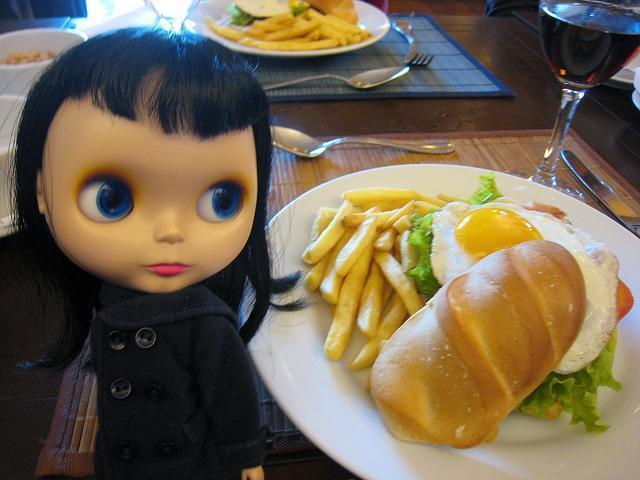Does the caption "The person is touching the sandwich." correctly depict the image?
Answer yes or no. No. Is the caption "The dining table is on the sandwich." a true representation of the image?
Answer yes or no. No. Does the image validate the caption "The sandwich is at the right side of the person."?
Answer yes or no. Yes. 